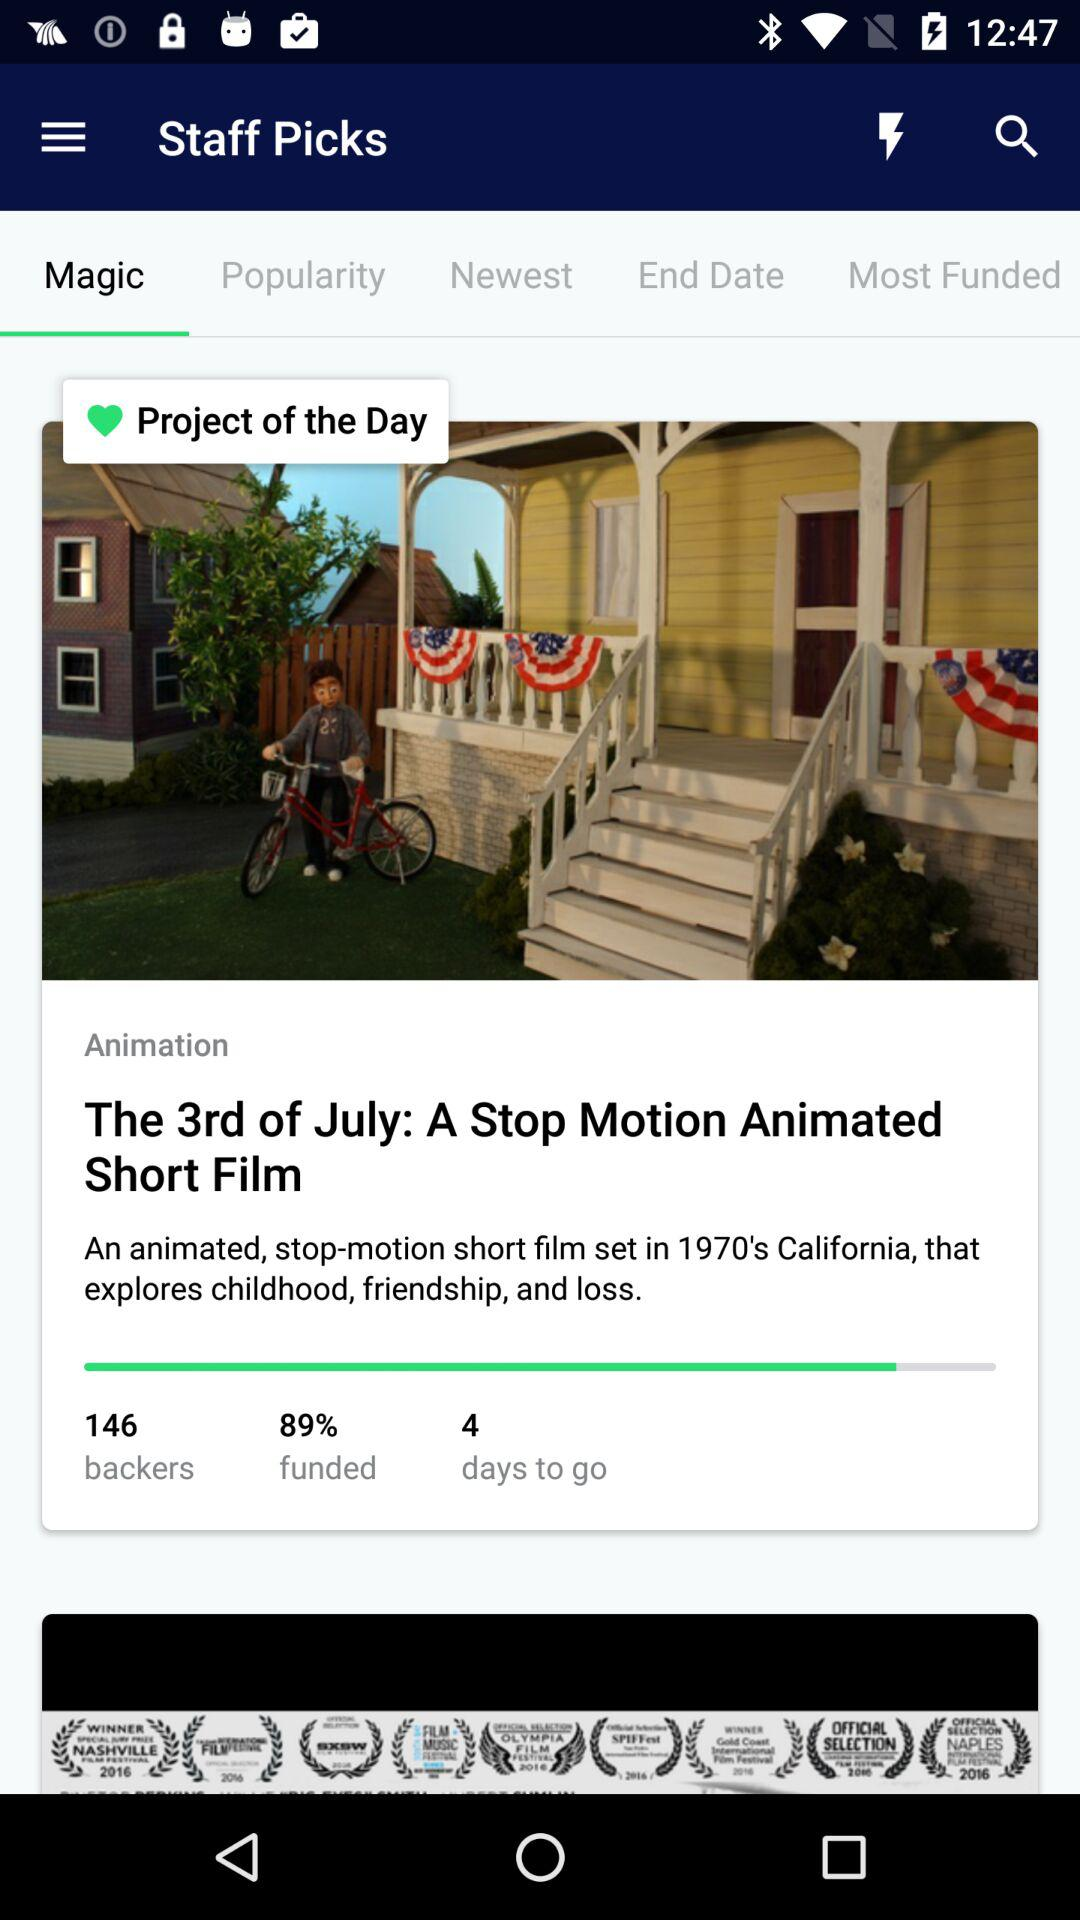Which option has been selected? The selected option is "Magic". 